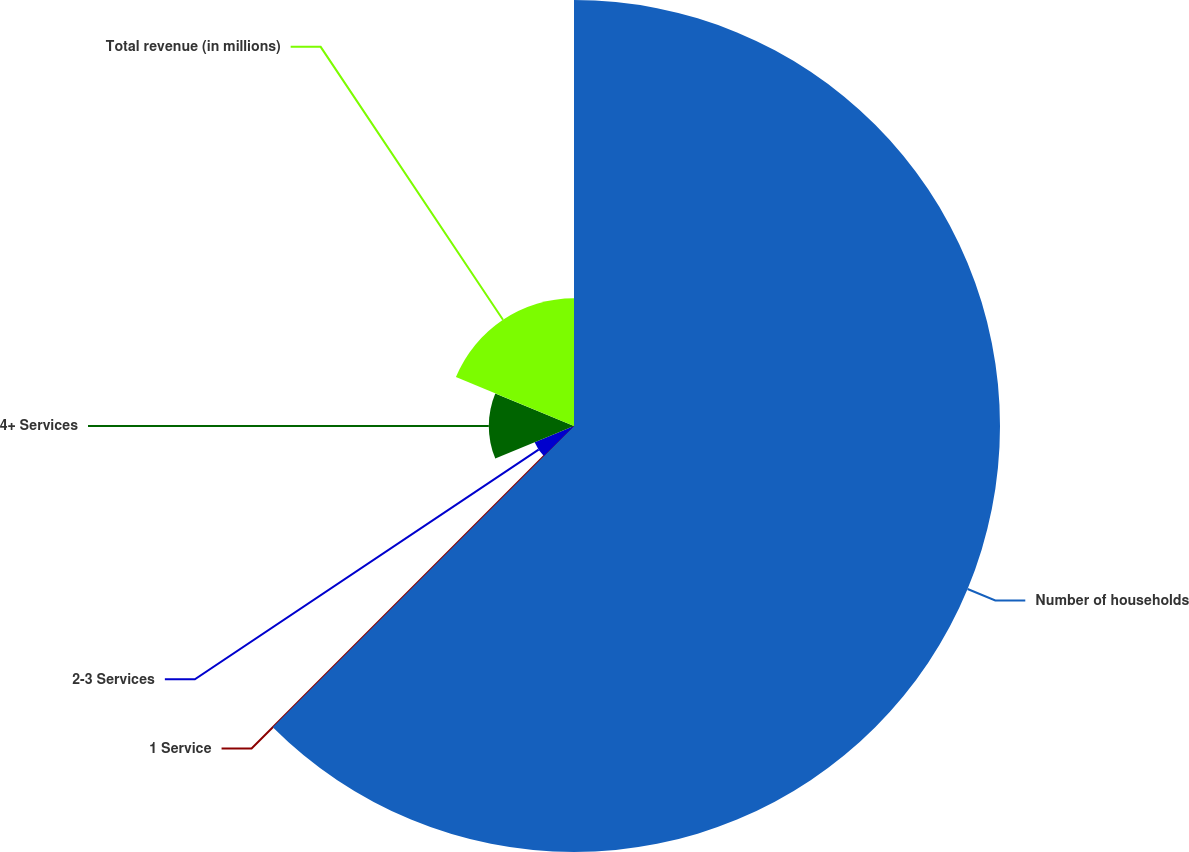Convert chart to OTSL. <chart><loc_0><loc_0><loc_500><loc_500><pie_chart><fcel>Number of households<fcel>1 Service<fcel>2-3 Services<fcel>4+ Services<fcel>Total revenue (in millions)<nl><fcel>62.5%<fcel>0.0%<fcel>6.25%<fcel>12.5%<fcel>18.75%<nl></chart> 